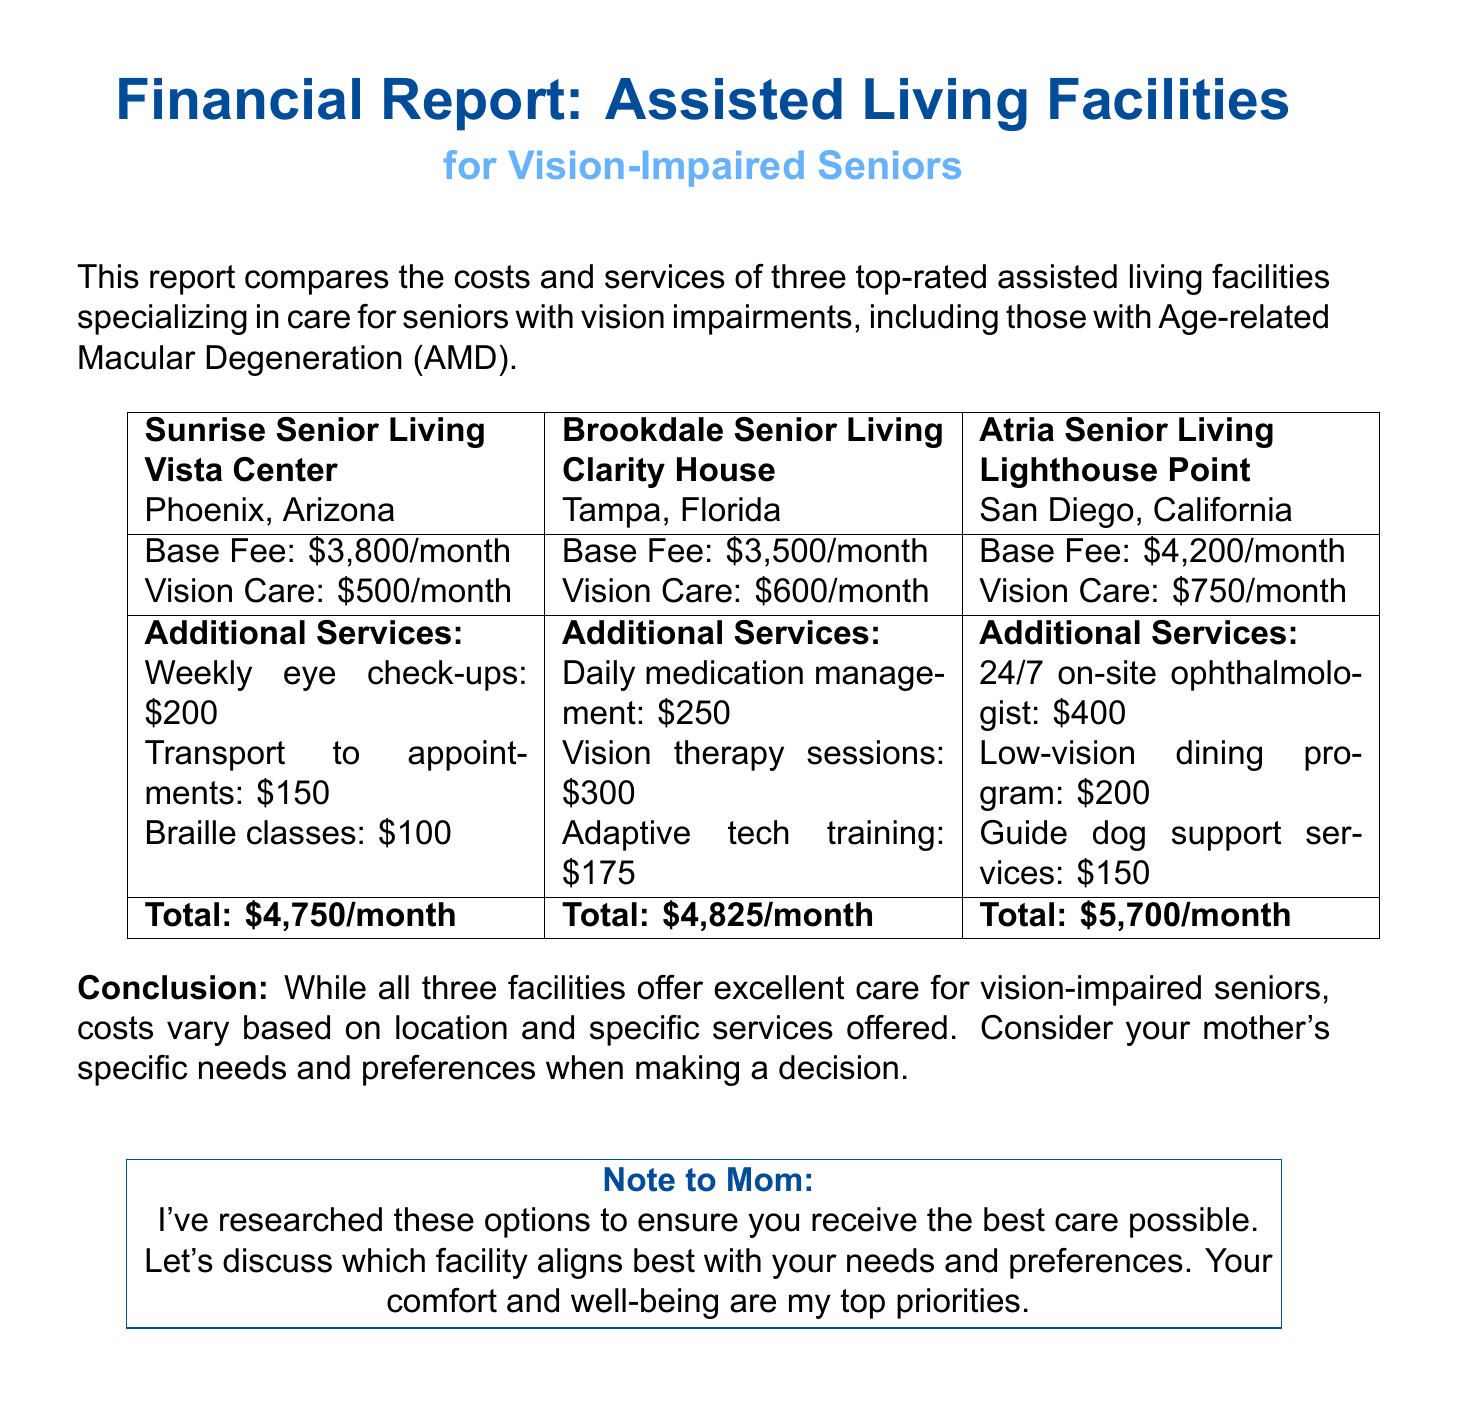What is the monthly base fee for Sunrise Senior Living? The monthly base fee for Sunrise Senior Living is stated in the document.
Answer: $3,800 What additional service costs $250 at Brookdale Senior Living? The document lists additional services and their costs for Brookdale Senior Living.
Answer: Daily medication management What is the total monthly cost at Atria Senior Living? The document provides total monthly costs for each facility, specifically for Atria Senior Living.
Answer: $5,700 Which facility is located in San Diego, California? The document mentions the locations of each facility, identifying the one in San Diego.
Answer: Atria Senior Living - Lighthouse Point What is included in the vision care package for Sunrise Senior Living? The document outlines the vision care package costs for each facility, specifically for Sunrise Senior Living.
Answer: $500 Which facility offers 24/7 on-site ophthalmologist? The document lists specific services associated with each facility, including 24/7 on-site ophthalmologist.
Answer: Atria Senior Living - Lighthouse Point How much does the Braille classes cost at Sunrise Senior Living? The document details the cost of Braille classes as listed under additional services for Sunrise Senior Living.
Answer: $100 What is the conclusion of the financial report? The conclusion is summarised in the document, reflecting on the services and costs of the facilities.
Answer: Costs vary based on location and specific services offered 